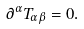Convert formula to latex. <formula><loc_0><loc_0><loc_500><loc_500>\partial ^ { \alpha } T _ { \alpha \beta } = 0 .</formula> 